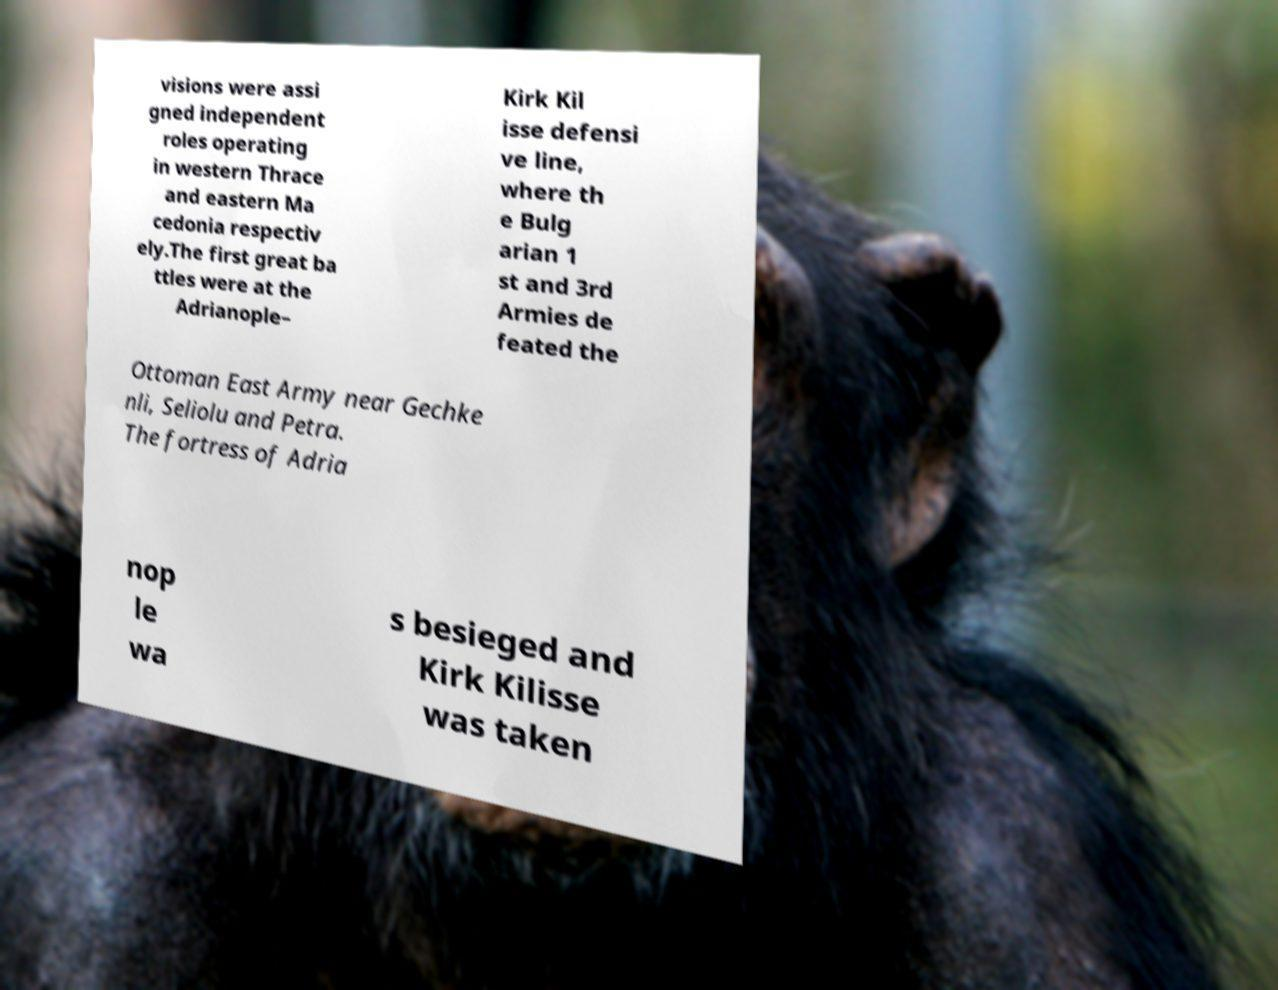Could you extract and type out the text from this image? visions were assi gned independent roles operating in western Thrace and eastern Ma cedonia respectiv ely.The first great ba ttles were at the Adrianople– Kirk Kil isse defensi ve line, where th e Bulg arian 1 st and 3rd Armies de feated the Ottoman East Army near Gechke nli, Seliolu and Petra. The fortress of Adria nop le wa s besieged and Kirk Kilisse was taken 